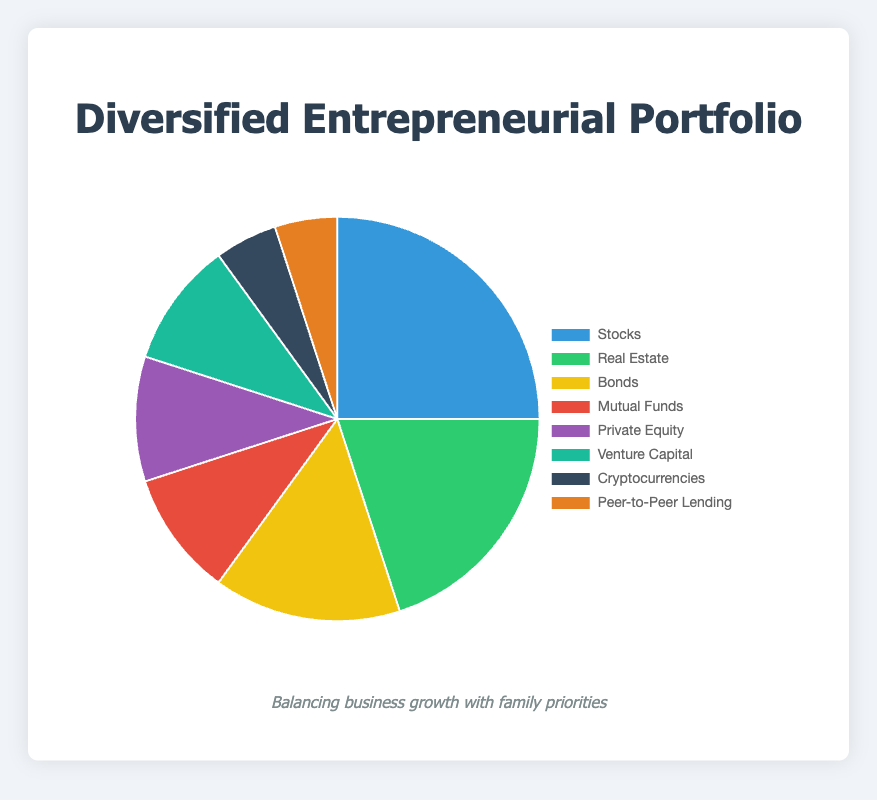What investment type has the highest percentage? The investment types and their percentages are visualized in the pie chart. The section labeled "Stocks" takes up the largest portion of the pie.
Answer: Stocks Which two investment types together make up 30% of the portfolio? From the pie chart, "Cryptocurrencies" make up 5% and "Peer-to-Peer Lending" make up 5%. Together, they add up to 10%. The next two smallest are "Mutual Funds" and "Private Equity" both at 10%. Adding these two gives 20%, making it a total of 30%.
Answer: Mutual Funds and Private Equity How much larger is the Stocks section compared to the Cryptocurrencies section? The "Stocks" section is 25%, and the "Cryptocurrencies" section is 5%. The difference is calculated as 25% - 5%.
Answer: 20% What is the combined percentage of Bonds and Venture Capital investments? The "Bonds" section is 15% and the "Venture Capital" section is 10%. Adding these percentages together gives 15% + 10%.
Answer: 25% Which investment type has the smallest percentage, and how is it colored? The sectors with the smallest percentages are "Cryptocurrencies" and "Peer-to-Peer Lending", each taking up 5%. The "Cryptocurrencies" section is colored dark blue and the "Peer-to-Peer Lending" section is colored orange.
Answer: Cryptocurrencies (dark blue) and Peer-to-Peer Lending (orange) Is the Real Estate investment larger or smaller than the combination of Bonds and Mutual Funds? "Real Estate" has a percentage of 20%, while "Bonds" are 15% and "Mutual Funds" are 10%. The combination of Bonds and Mutual Funds is 15% + 10% = 25%. 20% is less than 25%.
Answer: Smaller What color represents the Real Estate section in the pie chart? According to the color scheme provided, the "Real Estate" section is represented by green.
Answer: Green If the proportion of Venture Capital were increased by 5 percentage points, what would the new percentage be? Currently, "Venture Capital" is at 10%. Adding 5 percentage points results in 10% + 5%.
Answer: 15% What is the ratio of the Stocks percentage to the Peer-to-Peer Lending percentage? The percentage for "Stocks" is 25%, and for "Peer-to-Peer Lending" it is 5%. The ratio is calculated as 25% / 5%.
Answer: 5:1 How does the percentage of Bonds compare to the percentage of Private Equity and Venture Capital combined? "Bonds" have a percentage of 15%. "Private Equity" and "Venture Capital" both have 10% each. Their combined percentage is 10% + 10% = 20%. 15% is less than 20%.
Answer: Less than 